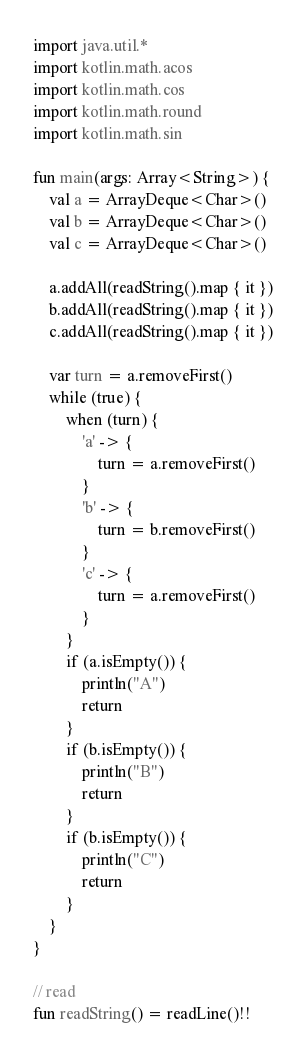Convert code to text. <code><loc_0><loc_0><loc_500><loc_500><_Kotlin_>import java.util.*
import kotlin.math.acos
import kotlin.math.cos
import kotlin.math.round
import kotlin.math.sin

fun main(args: Array<String>) {
    val a = ArrayDeque<Char>()
    val b = ArrayDeque<Char>()
    val c = ArrayDeque<Char>()

    a.addAll(readString().map { it })
    b.addAll(readString().map { it })
    c.addAll(readString().map { it })

    var turn = a.removeFirst()
    while (true) {
        when (turn) {
            'a' -> {
                turn = a.removeFirst()
            }
            'b' -> {
                turn = b.removeFirst()
            }
            'c' -> {
                turn = a.removeFirst()
            }
        }
        if (a.isEmpty()) {
            println("A")
            return
        }
        if (b.isEmpty()) {
            println("B")
            return
        }
        if (b.isEmpty()) {
            println("C")
            return
        }
    }
}

// read
fun readString() = readLine()!!</code> 